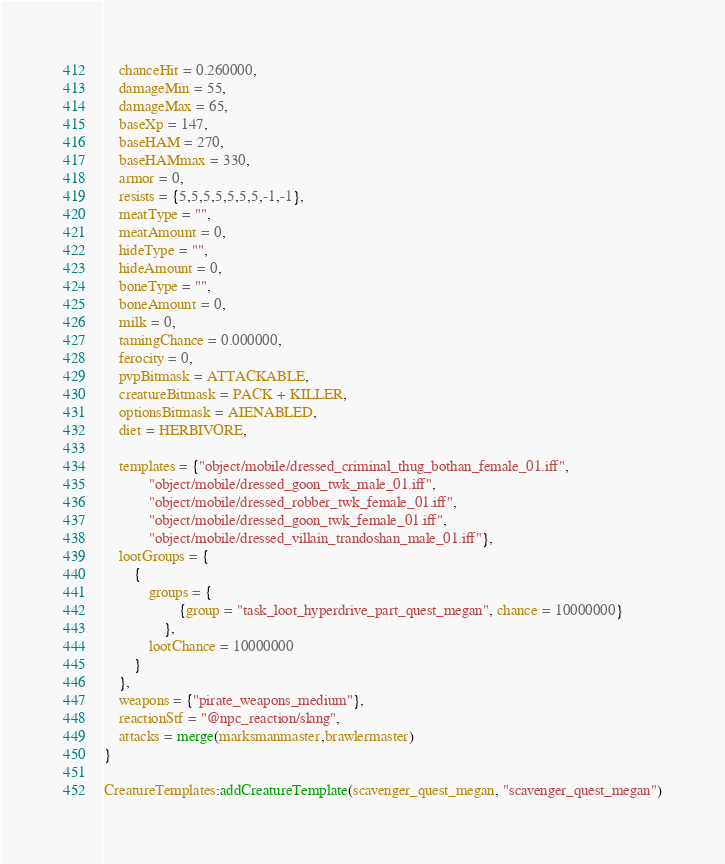Convert code to text. <code><loc_0><loc_0><loc_500><loc_500><_Lua_>	chanceHit = 0.260000,
	damageMin = 55,
	damageMax = 65,
	baseXp = 147,
	baseHAM = 270,
	baseHAMmax = 330,
	armor = 0,
	resists = {5,5,5,5,5,5,5,-1,-1},
	meatType = "",
	meatAmount = 0,
	hideType = "",
	hideAmount = 0,
	boneType = "",
	boneAmount = 0,
	milk = 0,
	tamingChance = 0.000000,
	ferocity = 0,
	pvpBitmask = ATTACKABLE,
	creatureBitmask = PACK + KILLER,
	optionsBitmask = AIENABLED,
	diet = HERBIVORE,

	templates = {"object/mobile/dressed_criminal_thug_bothan_female_01.iff",
			"object/mobile/dressed_goon_twk_male_01.iff",
			"object/mobile/dressed_robber_twk_female_01.iff",
			"object/mobile/dressed_goon_twk_female_01.iff",
			"object/mobile/dressed_villain_trandoshan_male_01.iff"},
	lootGroups = {
		{
			groups = {
					{group = "task_loot_hyperdrive_part_quest_megan", chance = 10000000}
				},
			lootChance = 10000000
		}
	},
	weapons = {"pirate_weapons_medium"},
	reactionStf = "@npc_reaction/slang",
	attacks = merge(marksmanmaster,brawlermaster)
}

CreatureTemplates:addCreatureTemplate(scavenger_quest_megan, "scavenger_quest_megan")
</code> 